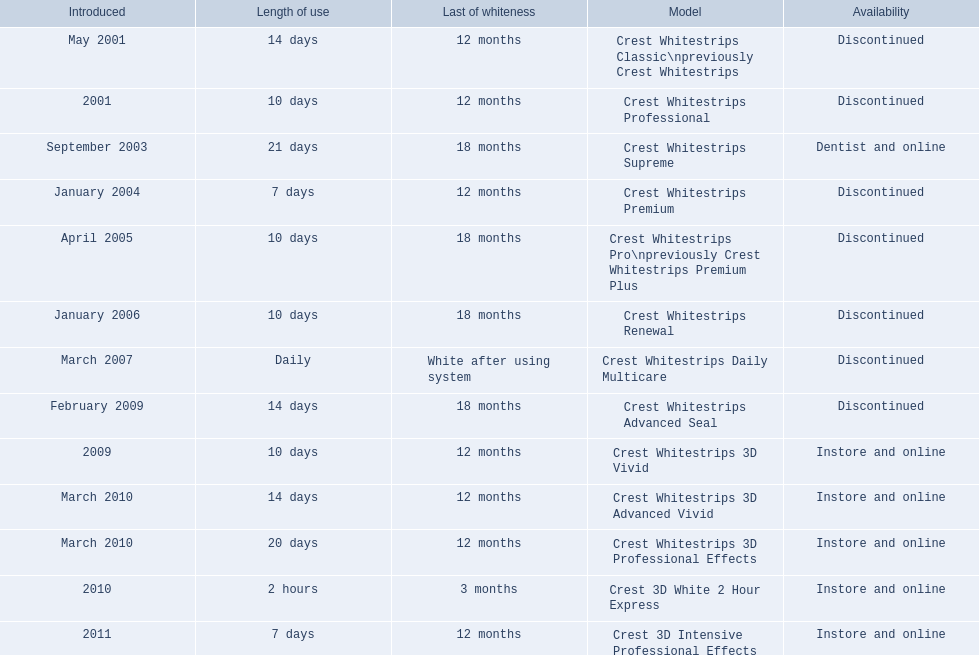Which of these products are discontinued? Crest Whitestrips Classic\npreviously Crest Whitestrips, Crest Whitestrips Professional, Crest Whitestrips Premium, Crest Whitestrips Pro\npreviously Crest Whitestrips Premium Plus, Crest Whitestrips Renewal, Crest Whitestrips Daily Multicare, Crest Whitestrips Advanced Seal. Which of these products have a 14 day length of use? Crest Whitestrips Classic\npreviously Crest Whitestrips, Crest Whitestrips Advanced Seal. Which of these products was introduced in 2009? Crest Whitestrips Advanced Seal. 